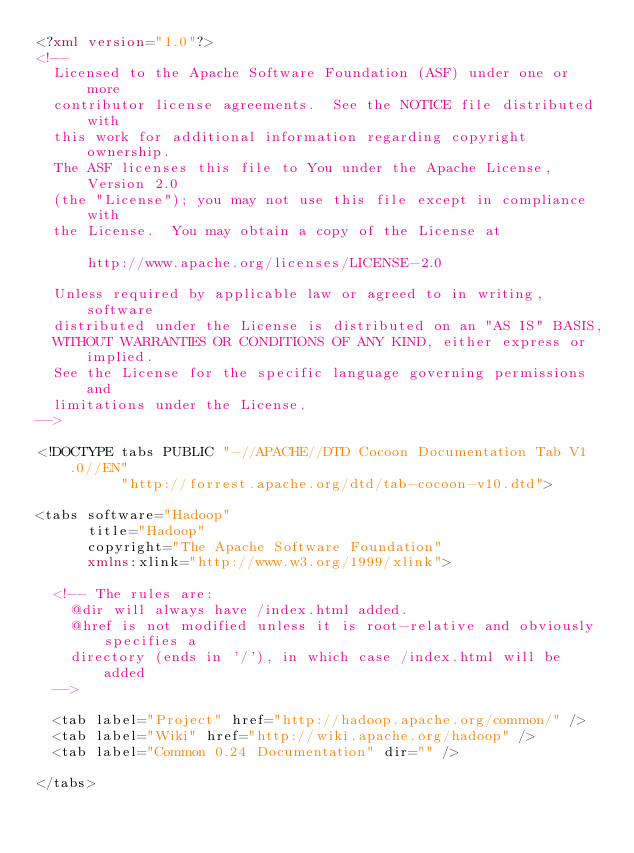Convert code to text. <code><loc_0><loc_0><loc_500><loc_500><_XML_><?xml version="1.0"?>
<!--
  Licensed to the Apache Software Foundation (ASF) under one or more
  contributor license agreements.  See the NOTICE file distributed with
  this work for additional information regarding copyright ownership.
  The ASF licenses this file to You under the Apache License, Version 2.0
  (the "License"); you may not use this file except in compliance with
  the License.  You may obtain a copy of the License at

      http://www.apache.org/licenses/LICENSE-2.0

  Unless required by applicable law or agreed to in writing, software
  distributed under the License is distributed on an "AS IS" BASIS,
  WITHOUT WARRANTIES OR CONDITIONS OF ANY KIND, either express or implied.
  See the License for the specific language governing permissions and
  limitations under the License.
-->

<!DOCTYPE tabs PUBLIC "-//APACHE//DTD Cocoon Documentation Tab V1.0//EN" 
          "http://forrest.apache.org/dtd/tab-cocoon-v10.dtd">

<tabs software="Hadoop"
      title="Hadoop"
      copyright="The Apache Software Foundation"
      xmlns:xlink="http://www.w3.org/1999/xlink">

  <!-- The rules are:
    @dir will always have /index.html added.
    @href is not modified unless it is root-relative and obviously specifies a
    directory (ends in '/'), in which case /index.html will be added
  -->

  <tab label="Project" href="http://hadoop.apache.org/common/" />
  <tab label="Wiki" href="http://wiki.apache.org/hadoop" />
  <tab label="Common 0.24 Documentation" dir="" />  
  
</tabs>
</code> 